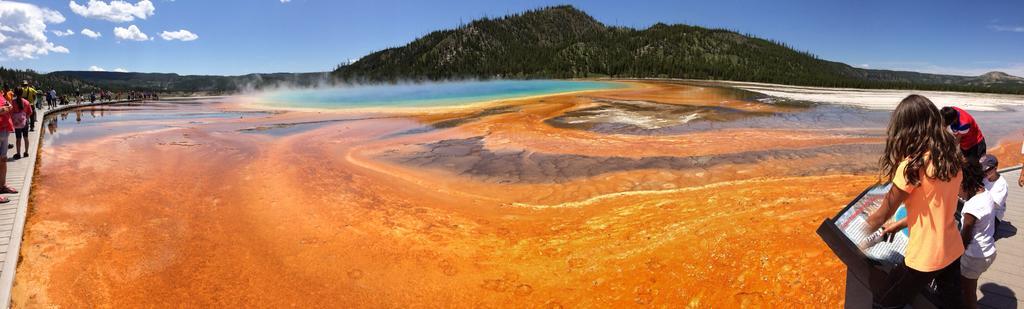Describe this image in one or two sentences. In the bottom right corner of the image few people are standing. In the middle of the image we can see water. Behind the water we can see some hills. At the top of the image we can see some clouds in the sky. On the left side of the image few people are standing. 